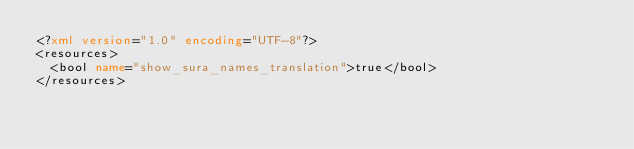Convert code to text. <code><loc_0><loc_0><loc_500><loc_500><_XML_><?xml version="1.0" encoding="UTF-8"?>
<resources>
  <bool name="show_sura_names_translation">true</bool>
</resources>
</code> 